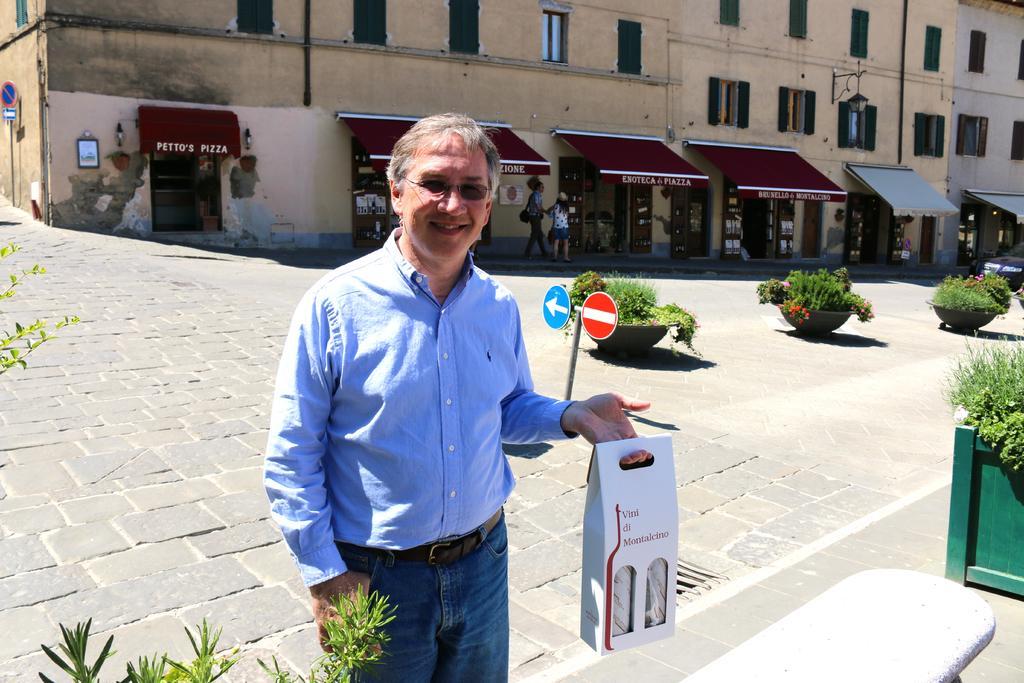In one or two sentences, can you explain what this image depicts? In the foreground of this image, there is a man standing and holding a cardboard object and also on the bottom, it seems like bench and a plant. In the background, there are plants, signboard, pavement and the buildings and two persons walking on the side path. 